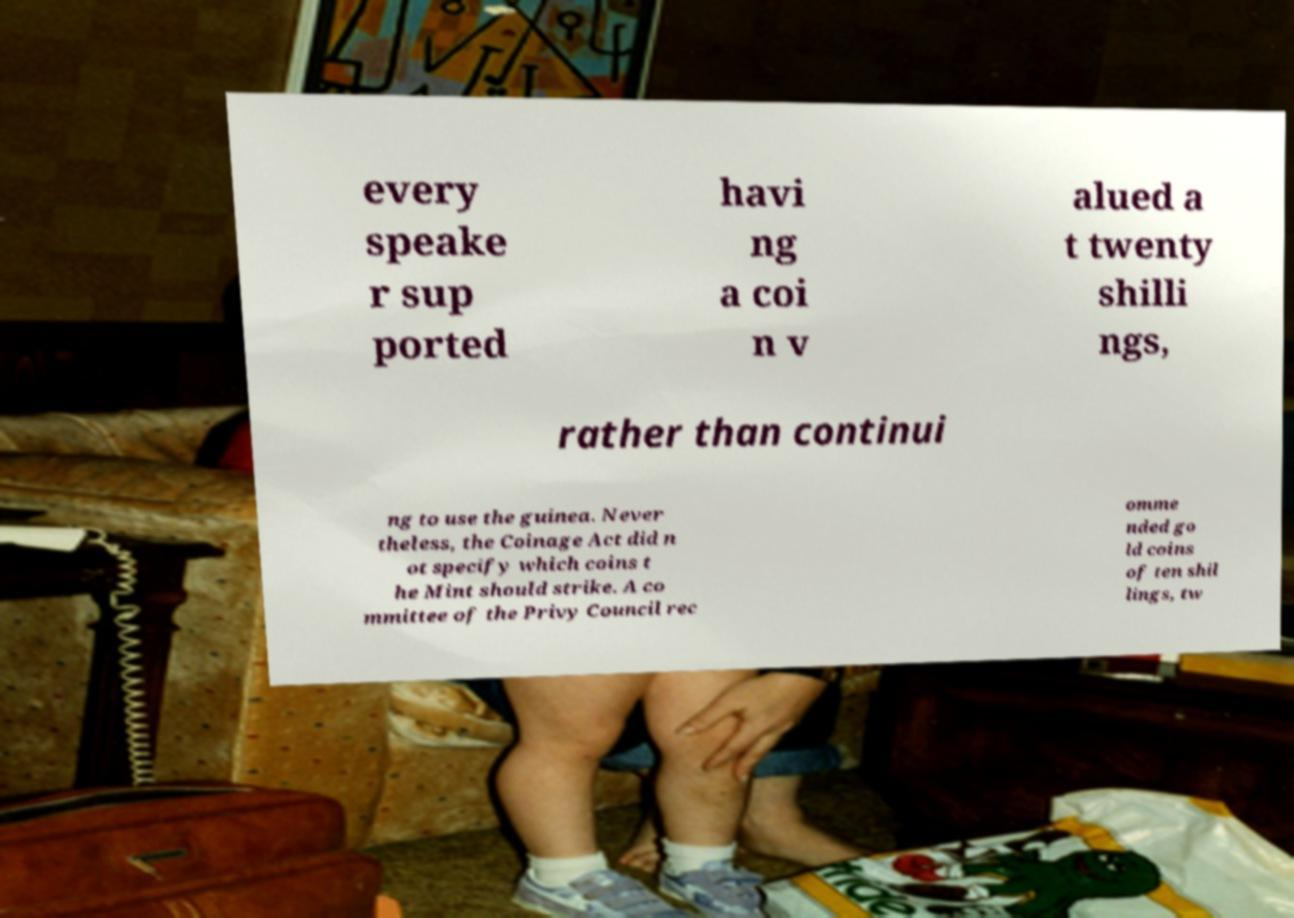Can you read and provide the text displayed in the image?This photo seems to have some interesting text. Can you extract and type it out for me? every speake r sup ported havi ng a coi n v alued a t twenty shilli ngs, rather than continui ng to use the guinea. Never theless, the Coinage Act did n ot specify which coins t he Mint should strike. A co mmittee of the Privy Council rec omme nded go ld coins of ten shil lings, tw 